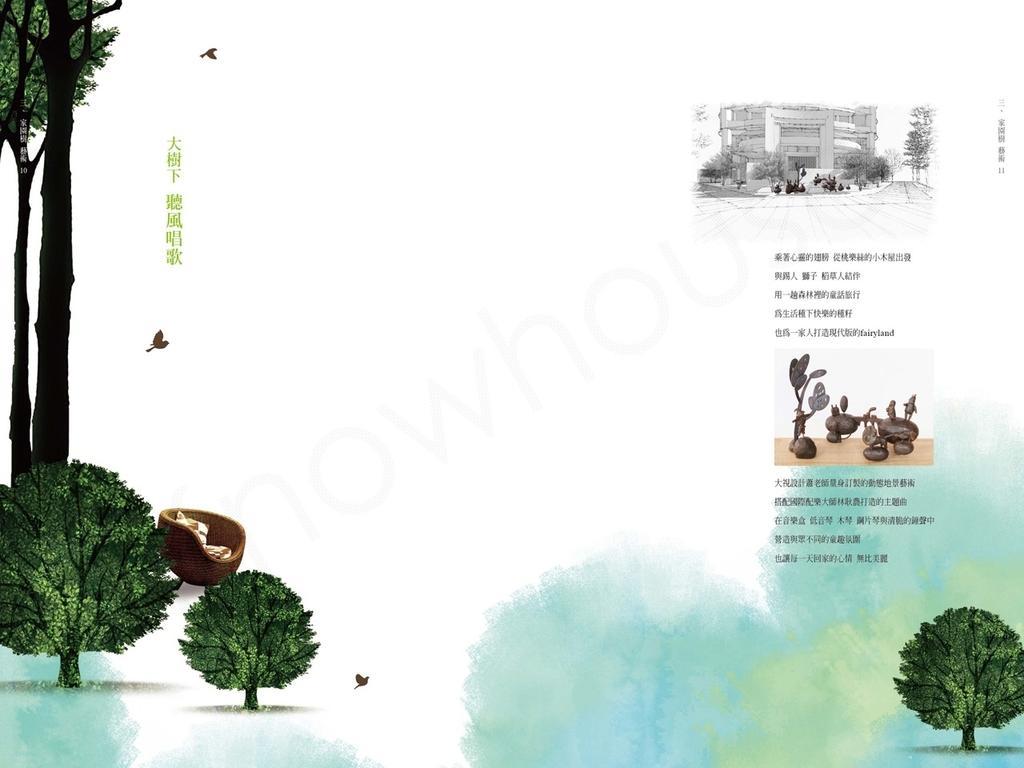Describe this image in one or two sentences. In this picture there is a paper poster. On the left side there are some trees and on the right we can see a small photography and quotes. 